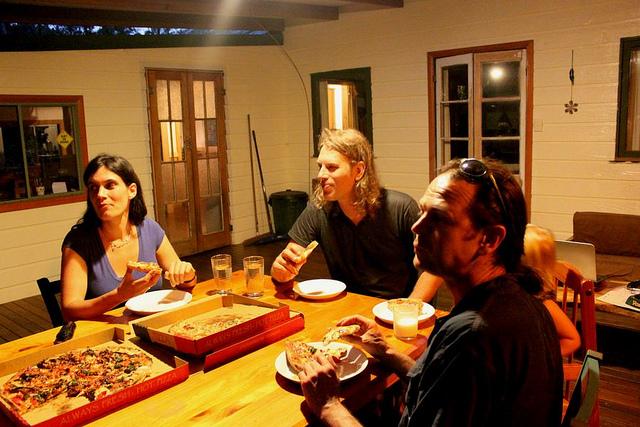What kind of pizza are they eating?
Be succinct. Supreme. Which person looks kind of like Tommy Lee Jones?
Short answer required. Right. What are they eating?
Keep it brief. Pizza. How many people are in the photo?
Quick response, please. 4. 